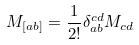<formula> <loc_0><loc_0><loc_500><loc_500>M _ { [ a b ] } = \frac { 1 } { 2 ! } \delta _ { a b } ^ { c d } M _ { c d }</formula> 